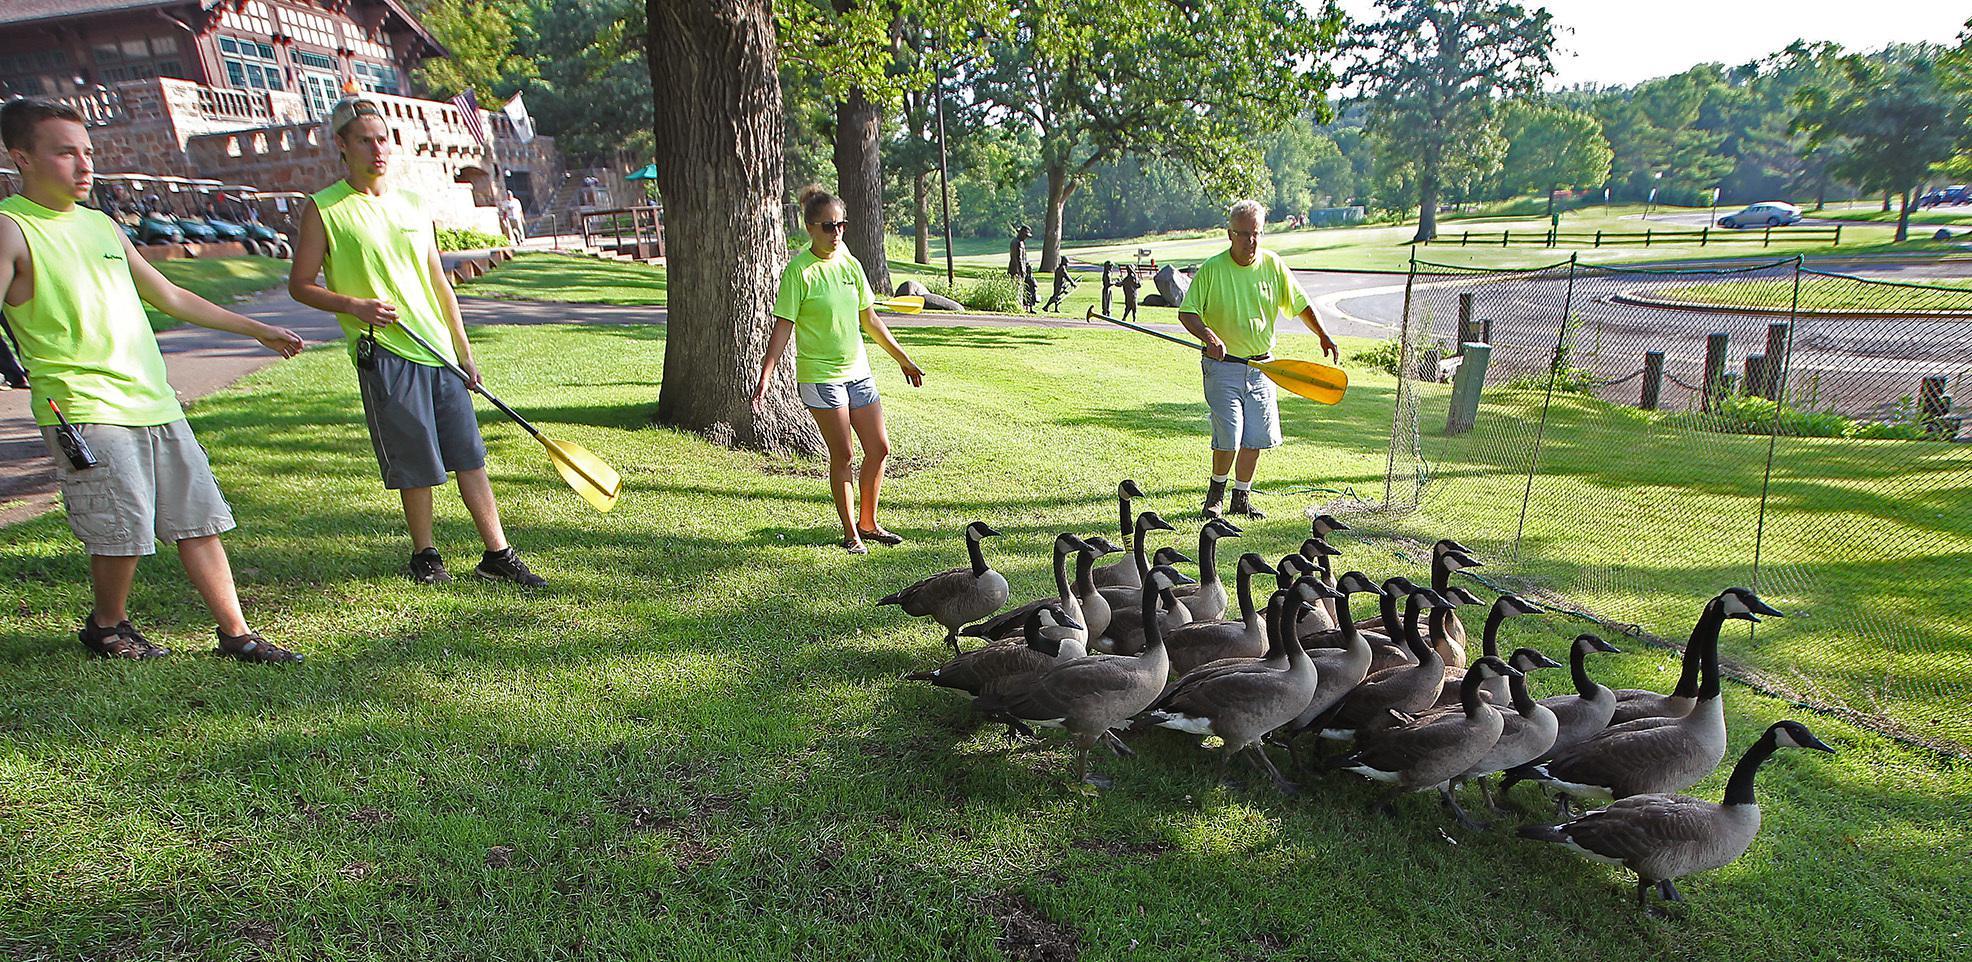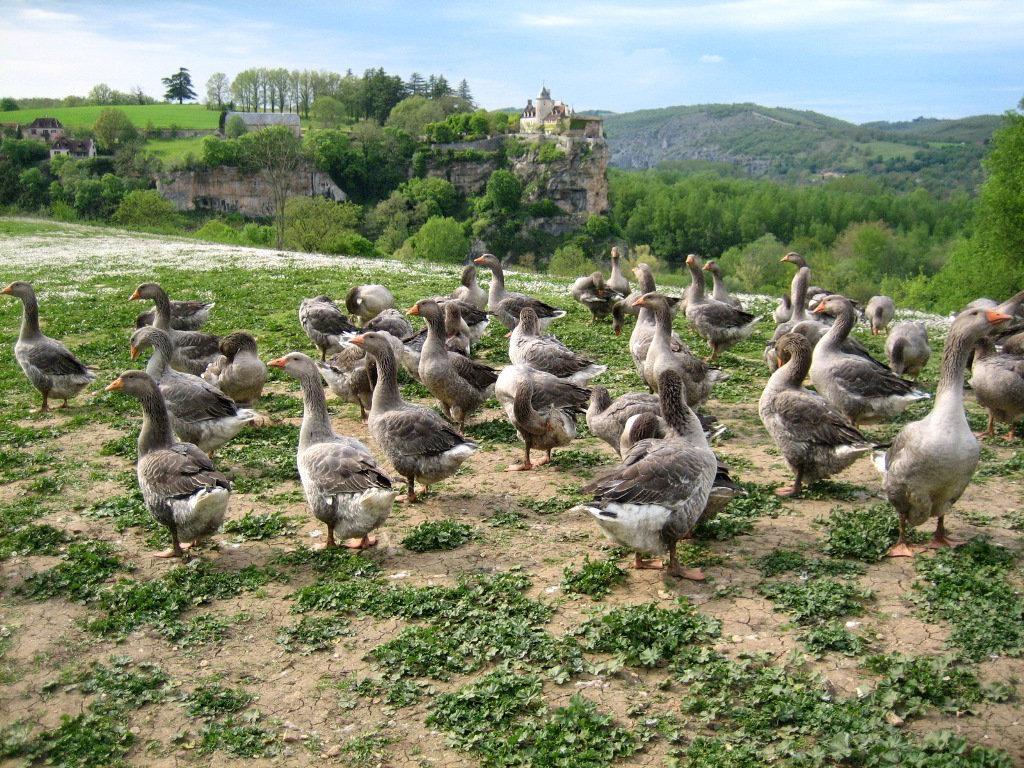The first image is the image on the left, the second image is the image on the right. For the images displayed, is the sentence "There are multiple birds walking and grazing on patchy grass with dirt showing." factually correct? Answer yes or no. Yes. The first image is the image on the left, the second image is the image on the right. Analyze the images presented: Is the assertion "The only living creatures in the image on the left are either adult or juvenile Canadian geese, too many to count." valid? Answer yes or no. No. 